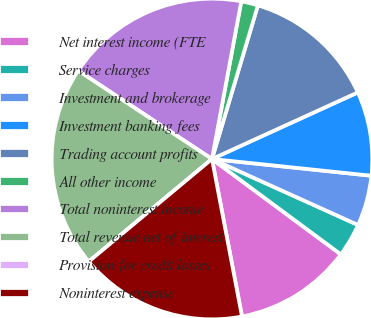Convert chart. <chart><loc_0><loc_0><loc_500><loc_500><pie_chart><fcel>Net interest income (FTE<fcel>Service charges<fcel>Investment and brokerage<fcel>Investment banking fees<fcel>Trading account profits<fcel>All other income<fcel>Total noninterest income<fcel>Total revenue net of interest<fcel>Provision for credit losses<fcel>Noninterest expense<nl><fcel>11.86%<fcel>3.39%<fcel>5.09%<fcel>8.48%<fcel>13.56%<fcel>1.7%<fcel>18.64%<fcel>20.34%<fcel>0.0%<fcel>16.95%<nl></chart> 